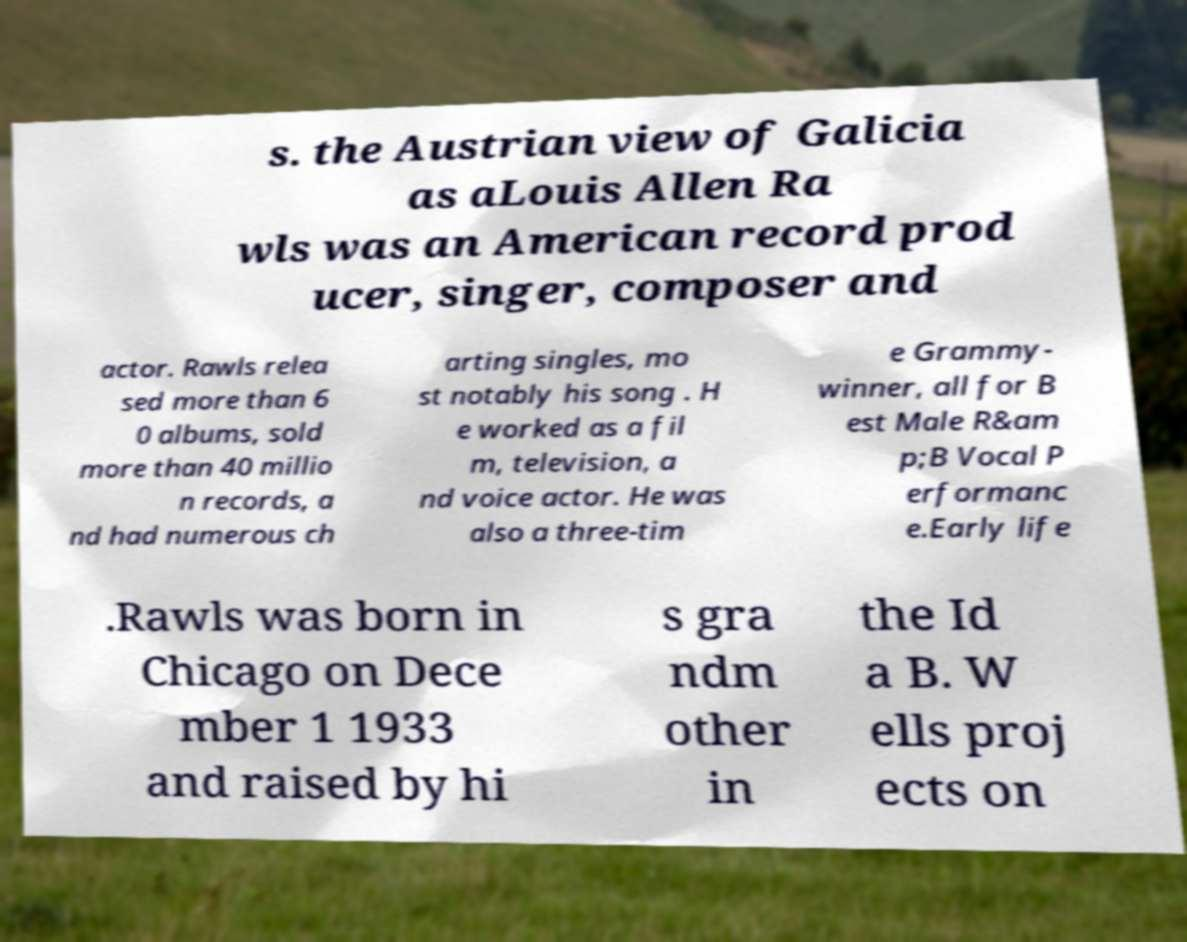Could you assist in decoding the text presented in this image and type it out clearly? s. the Austrian view of Galicia as aLouis Allen Ra wls was an American record prod ucer, singer, composer and actor. Rawls relea sed more than 6 0 albums, sold more than 40 millio n records, a nd had numerous ch arting singles, mo st notably his song . H e worked as a fil m, television, a nd voice actor. He was also a three-tim e Grammy- winner, all for B est Male R&am p;B Vocal P erformanc e.Early life .Rawls was born in Chicago on Dece mber 1 1933 and raised by hi s gra ndm other in the Id a B. W ells proj ects on 